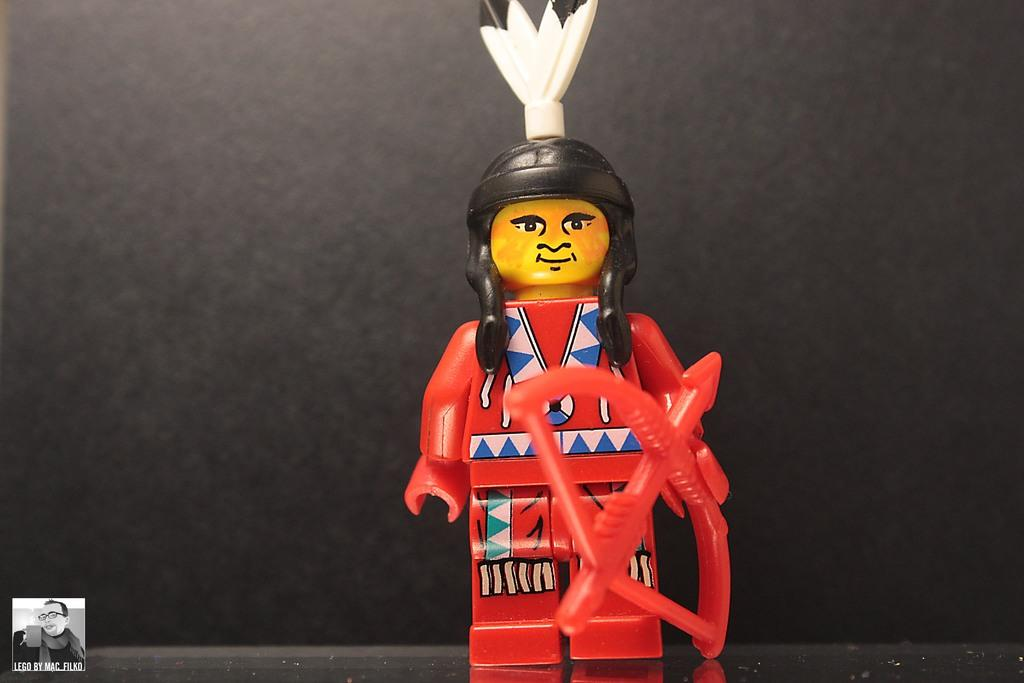What type of toy is in the image? There is a Lego toy of a person in the image. What is the Lego person holding? The Lego person is holding a bow and arrow. Where is the Lego toy placed? The Lego toy is placed on a surface. What can be seen in the bottom left corner of the image? There is a logo in the bottom left corner of the image. What type of trees can be seen in the image? There are no trees present in the image; it features a Lego toy of a person holding a bow and arrow. What time of day is depicted in the image? The time of day cannot be determined from the image, as it only shows a Lego toy and a logo. 